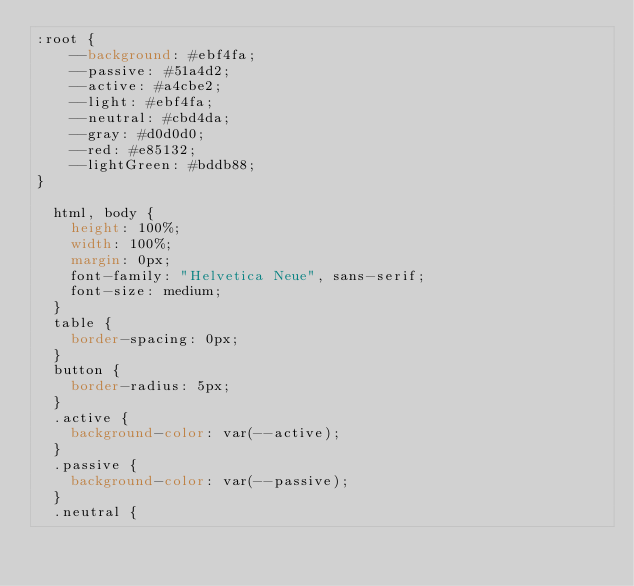<code> <loc_0><loc_0><loc_500><loc_500><_CSS_>:root {
    --background: #ebf4fa;
    --passive: #51a4d2;
    --active: #a4cbe2;
    --light: #ebf4fa;
    --neutral: #cbd4da;
    --gray: #d0d0d0;
    --red: #e85132;
    --lightGreen: #bddb88;
}

  html, body {
    height: 100%;
    width: 100%;
    margin: 0px;
    font-family: "Helvetica Neue", sans-serif;
    font-size: medium;
  }
  table {
    border-spacing: 0px;
  }
  button {
    border-radius: 5px;
  }
  .active {
    background-color: var(--active);
  }
  .passive {
    background-color: var(--passive);
  }
  .neutral {</code> 